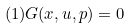<formula> <loc_0><loc_0><loc_500><loc_500>( 1 ) G ( x , u , p ) = 0</formula> 